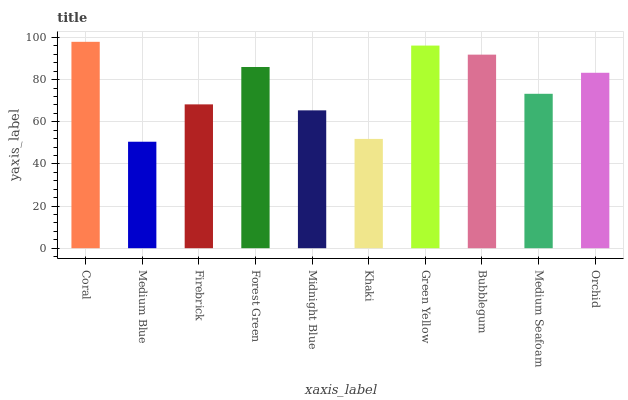Is Medium Blue the minimum?
Answer yes or no. Yes. Is Coral the maximum?
Answer yes or no. Yes. Is Firebrick the minimum?
Answer yes or no. No. Is Firebrick the maximum?
Answer yes or no. No. Is Firebrick greater than Medium Blue?
Answer yes or no. Yes. Is Medium Blue less than Firebrick?
Answer yes or no. Yes. Is Medium Blue greater than Firebrick?
Answer yes or no. No. Is Firebrick less than Medium Blue?
Answer yes or no. No. Is Orchid the high median?
Answer yes or no. Yes. Is Medium Seafoam the low median?
Answer yes or no. Yes. Is Firebrick the high median?
Answer yes or no. No. Is Forest Green the low median?
Answer yes or no. No. 